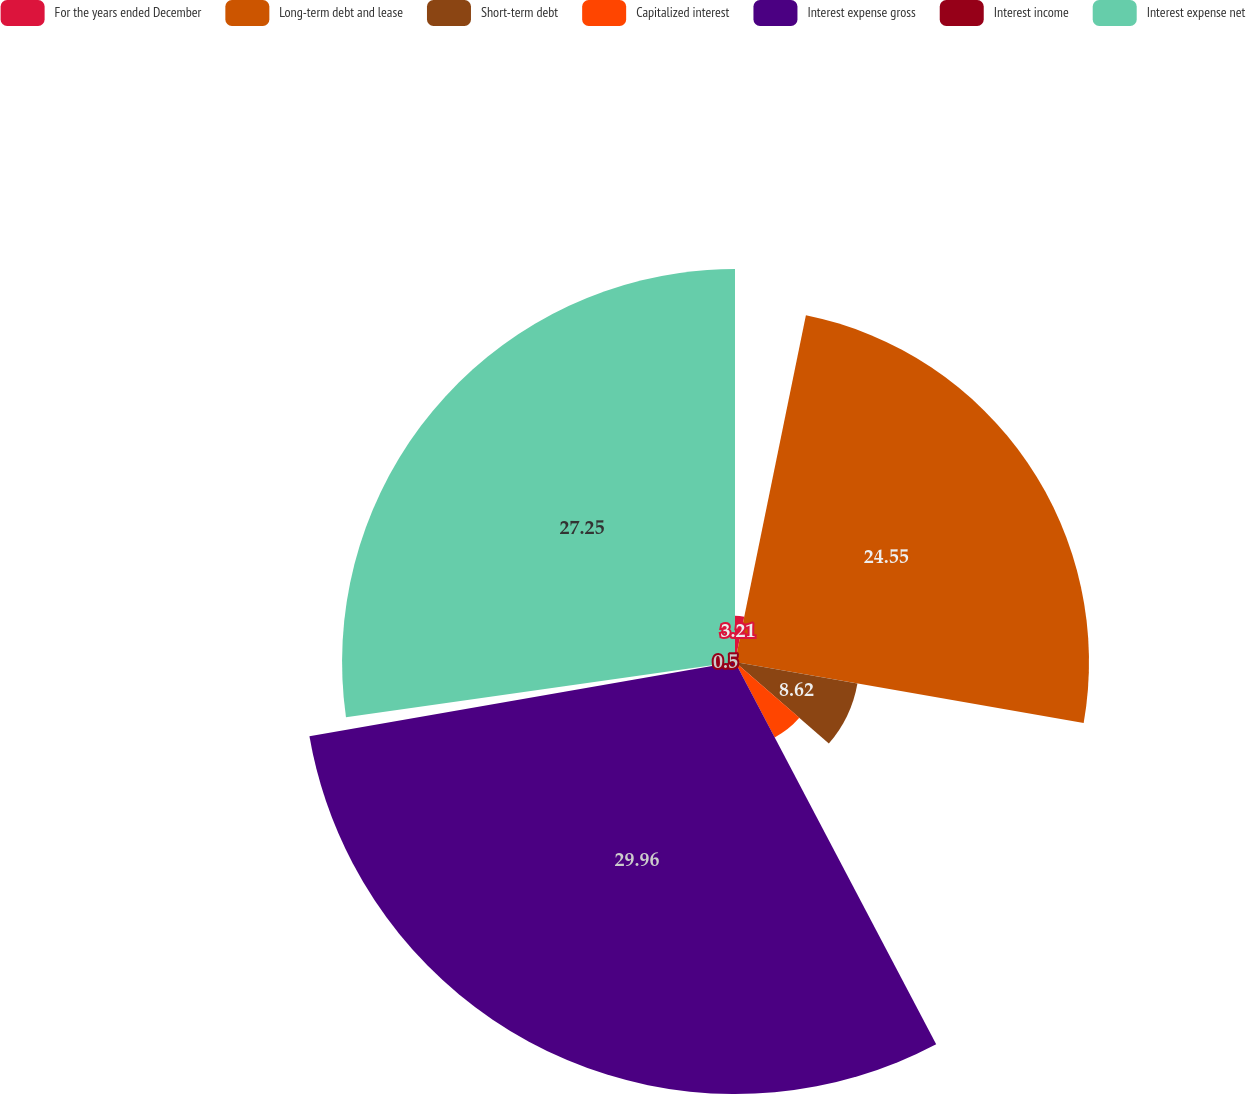<chart> <loc_0><loc_0><loc_500><loc_500><pie_chart><fcel>For the years ended December<fcel>Long-term debt and lease<fcel>Short-term debt<fcel>Capitalized interest<fcel>Interest expense gross<fcel>Interest income<fcel>Interest expense net<nl><fcel>3.21%<fcel>24.55%<fcel>8.62%<fcel>5.91%<fcel>29.96%<fcel>0.5%<fcel>27.25%<nl></chart> 